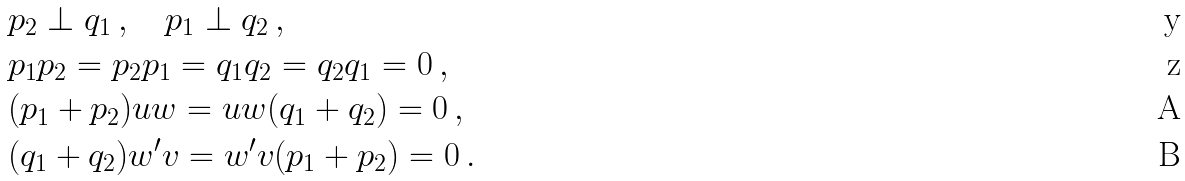Convert formula to latex. <formula><loc_0><loc_0><loc_500><loc_500>& p _ { 2 } \perp q _ { 1 } \, , \quad p _ { 1 } \perp q _ { 2 } \, , \\ & p _ { 1 } p _ { 2 } = p _ { 2 } p _ { 1 } = q _ { 1 } q _ { 2 } = q _ { 2 } q _ { 1 } = 0 \, , \\ & ( p _ { 1 } + p _ { 2 } ) u w = u w ( q _ { 1 } + q _ { 2 } ) = 0 \, , \\ & ( q _ { 1 } + q _ { 2 } ) w ^ { \prime } v = w ^ { \prime } v ( p _ { 1 } + p _ { 2 } ) = 0 \, .</formula> 